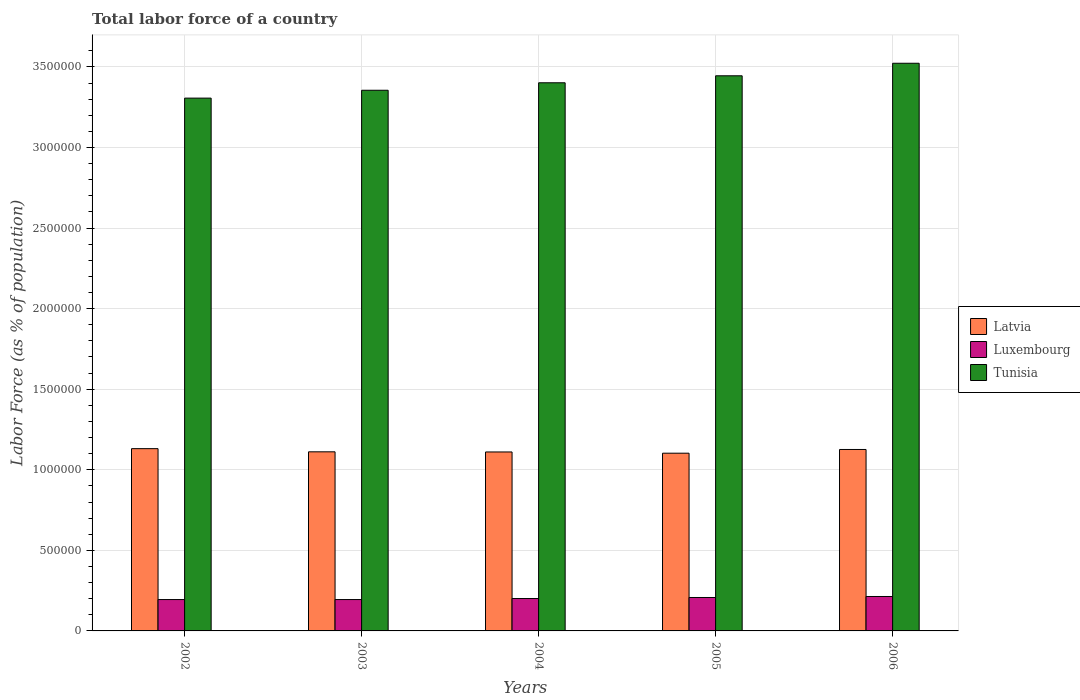How many different coloured bars are there?
Your answer should be very brief. 3. How many groups of bars are there?
Keep it short and to the point. 5. Are the number of bars on each tick of the X-axis equal?
Ensure brevity in your answer.  Yes. How many bars are there on the 2nd tick from the left?
Your response must be concise. 3. How many bars are there on the 2nd tick from the right?
Your response must be concise. 3. In how many cases, is the number of bars for a given year not equal to the number of legend labels?
Your response must be concise. 0. What is the percentage of labor force in Latvia in 2006?
Your response must be concise. 1.13e+06. Across all years, what is the maximum percentage of labor force in Tunisia?
Ensure brevity in your answer.  3.52e+06. Across all years, what is the minimum percentage of labor force in Latvia?
Offer a terse response. 1.10e+06. In which year was the percentage of labor force in Tunisia minimum?
Your answer should be compact. 2002. What is the total percentage of labor force in Latvia in the graph?
Your answer should be compact. 5.58e+06. What is the difference between the percentage of labor force in Luxembourg in 2003 and that in 2006?
Your answer should be very brief. -1.90e+04. What is the difference between the percentage of labor force in Luxembourg in 2003 and the percentage of labor force in Tunisia in 2002?
Your response must be concise. -3.11e+06. What is the average percentage of labor force in Tunisia per year?
Ensure brevity in your answer.  3.41e+06. In the year 2003, what is the difference between the percentage of labor force in Tunisia and percentage of labor force in Luxembourg?
Make the answer very short. 3.16e+06. In how many years, is the percentage of labor force in Luxembourg greater than 600000 %?
Your answer should be compact. 0. What is the ratio of the percentage of labor force in Tunisia in 2004 to that in 2005?
Make the answer very short. 0.99. What is the difference between the highest and the second highest percentage of labor force in Luxembourg?
Your answer should be compact. 6194. What is the difference between the highest and the lowest percentage of labor force in Luxembourg?
Offer a very short reply. 1.90e+04. In how many years, is the percentage of labor force in Latvia greater than the average percentage of labor force in Latvia taken over all years?
Ensure brevity in your answer.  2. Is the sum of the percentage of labor force in Latvia in 2003 and 2005 greater than the maximum percentage of labor force in Luxembourg across all years?
Give a very brief answer. Yes. What does the 2nd bar from the left in 2005 represents?
Your answer should be very brief. Luxembourg. What does the 3rd bar from the right in 2005 represents?
Make the answer very short. Latvia. Is it the case that in every year, the sum of the percentage of labor force in Tunisia and percentage of labor force in Latvia is greater than the percentage of labor force in Luxembourg?
Give a very brief answer. Yes. How many bars are there?
Keep it short and to the point. 15. Does the graph contain grids?
Offer a very short reply. Yes. How many legend labels are there?
Keep it short and to the point. 3. How are the legend labels stacked?
Keep it short and to the point. Vertical. What is the title of the graph?
Offer a terse response. Total labor force of a country. What is the label or title of the X-axis?
Your response must be concise. Years. What is the label or title of the Y-axis?
Ensure brevity in your answer.  Labor Force (as % of population). What is the Labor Force (as % of population) in Latvia in 2002?
Give a very brief answer. 1.13e+06. What is the Labor Force (as % of population) of Luxembourg in 2002?
Give a very brief answer. 1.95e+05. What is the Labor Force (as % of population) in Tunisia in 2002?
Ensure brevity in your answer.  3.31e+06. What is the Labor Force (as % of population) in Latvia in 2003?
Ensure brevity in your answer.  1.11e+06. What is the Labor Force (as % of population) in Luxembourg in 2003?
Your answer should be very brief. 1.95e+05. What is the Labor Force (as % of population) of Tunisia in 2003?
Your response must be concise. 3.36e+06. What is the Labor Force (as % of population) of Latvia in 2004?
Offer a very short reply. 1.11e+06. What is the Labor Force (as % of population) of Luxembourg in 2004?
Your answer should be compact. 2.01e+05. What is the Labor Force (as % of population) of Tunisia in 2004?
Give a very brief answer. 3.40e+06. What is the Labor Force (as % of population) in Latvia in 2005?
Provide a succinct answer. 1.10e+06. What is the Labor Force (as % of population) in Luxembourg in 2005?
Ensure brevity in your answer.  2.07e+05. What is the Labor Force (as % of population) in Tunisia in 2005?
Keep it short and to the point. 3.44e+06. What is the Labor Force (as % of population) of Latvia in 2006?
Provide a short and direct response. 1.13e+06. What is the Labor Force (as % of population) in Luxembourg in 2006?
Your answer should be compact. 2.14e+05. What is the Labor Force (as % of population) in Tunisia in 2006?
Offer a terse response. 3.52e+06. Across all years, what is the maximum Labor Force (as % of population) of Latvia?
Your response must be concise. 1.13e+06. Across all years, what is the maximum Labor Force (as % of population) in Luxembourg?
Offer a very short reply. 2.14e+05. Across all years, what is the maximum Labor Force (as % of population) of Tunisia?
Keep it short and to the point. 3.52e+06. Across all years, what is the minimum Labor Force (as % of population) in Latvia?
Your answer should be compact. 1.10e+06. Across all years, what is the minimum Labor Force (as % of population) in Luxembourg?
Provide a short and direct response. 1.95e+05. Across all years, what is the minimum Labor Force (as % of population) in Tunisia?
Keep it short and to the point. 3.31e+06. What is the total Labor Force (as % of population) in Latvia in the graph?
Provide a short and direct response. 5.58e+06. What is the total Labor Force (as % of population) of Luxembourg in the graph?
Keep it short and to the point. 1.01e+06. What is the total Labor Force (as % of population) in Tunisia in the graph?
Provide a short and direct response. 1.70e+07. What is the difference between the Labor Force (as % of population) in Latvia in 2002 and that in 2003?
Keep it short and to the point. 1.97e+04. What is the difference between the Labor Force (as % of population) in Luxembourg in 2002 and that in 2003?
Make the answer very short. 29. What is the difference between the Labor Force (as % of population) of Tunisia in 2002 and that in 2003?
Offer a terse response. -4.88e+04. What is the difference between the Labor Force (as % of population) in Latvia in 2002 and that in 2004?
Keep it short and to the point. 2.06e+04. What is the difference between the Labor Force (as % of population) in Luxembourg in 2002 and that in 2004?
Provide a short and direct response. -6340. What is the difference between the Labor Force (as % of population) in Tunisia in 2002 and that in 2004?
Provide a short and direct response. -9.52e+04. What is the difference between the Labor Force (as % of population) of Latvia in 2002 and that in 2005?
Your response must be concise. 2.82e+04. What is the difference between the Labor Force (as % of population) of Luxembourg in 2002 and that in 2005?
Keep it short and to the point. -1.27e+04. What is the difference between the Labor Force (as % of population) in Tunisia in 2002 and that in 2005?
Your answer should be very brief. -1.39e+05. What is the difference between the Labor Force (as % of population) in Latvia in 2002 and that in 2006?
Your response must be concise. 5134. What is the difference between the Labor Force (as % of population) in Luxembourg in 2002 and that in 2006?
Provide a succinct answer. -1.89e+04. What is the difference between the Labor Force (as % of population) in Tunisia in 2002 and that in 2006?
Your answer should be compact. -2.16e+05. What is the difference between the Labor Force (as % of population) in Latvia in 2003 and that in 2004?
Offer a terse response. 829. What is the difference between the Labor Force (as % of population) in Luxembourg in 2003 and that in 2004?
Your response must be concise. -6369. What is the difference between the Labor Force (as % of population) of Tunisia in 2003 and that in 2004?
Keep it short and to the point. -4.65e+04. What is the difference between the Labor Force (as % of population) of Latvia in 2003 and that in 2005?
Your answer should be very brief. 8469. What is the difference between the Labor Force (as % of population) of Luxembourg in 2003 and that in 2005?
Make the answer very short. -1.28e+04. What is the difference between the Labor Force (as % of population) in Tunisia in 2003 and that in 2005?
Give a very brief answer. -8.98e+04. What is the difference between the Labor Force (as % of population) of Latvia in 2003 and that in 2006?
Provide a short and direct response. -1.46e+04. What is the difference between the Labor Force (as % of population) of Luxembourg in 2003 and that in 2006?
Give a very brief answer. -1.90e+04. What is the difference between the Labor Force (as % of population) in Tunisia in 2003 and that in 2006?
Your response must be concise. -1.68e+05. What is the difference between the Labor Force (as % of population) of Latvia in 2004 and that in 2005?
Offer a terse response. 7640. What is the difference between the Labor Force (as % of population) of Luxembourg in 2004 and that in 2005?
Your answer should be very brief. -6407. What is the difference between the Labor Force (as % of population) in Tunisia in 2004 and that in 2005?
Keep it short and to the point. -4.34e+04. What is the difference between the Labor Force (as % of population) of Latvia in 2004 and that in 2006?
Provide a short and direct response. -1.54e+04. What is the difference between the Labor Force (as % of population) of Luxembourg in 2004 and that in 2006?
Your response must be concise. -1.26e+04. What is the difference between the Labor Force (as % of population) of Tunisia in 2004 and that in 2006?
Your response must be concise. -1.21e+05. What is the difference between the Labor Force (as % of population) of Latvia in 2005 and that in 2006?
Give a very brief answer. -2.31e+04. What is the difference between the Labor Force (as % of population) in Luxembourg in 2005 and that in 2006?
Provide a succinct answer. -6194. What is the difference between the Labor Force (as % of population) in Tunisia in 2005 and that in 2006?
Offer a very short reply. -7.77e+04. What is the difference between the Labor Force (as % of population) of Latvia in 2002 and the Labor Force (as % of population) of Luxembourg in 2003?
Provide a short and direct response. 9.36e+05. What is the difference between the Labor Force (as % of population) in Latvia in 2002 and the Labor Force (as % of population) in Tunisia in 2003?
Keep it short and to the point. -2.22e+06. What is the difference between the Labor Force (as % of population) in Luxembourg in 2002 and the Labor Force (as % of population) in Tunisia in 2003?
Offer a very short reply. -3.16e+06. What is the difference between the Labor Force (as % of population) of Latvia in 2002 and the Labor Force (as % of population) of Luxembourg in 2004?
Your response must be concise. 9.30e+05. What is the difference between the Labor Force (as % of population) in Latvia in 2002 and the Labor Force (as % of population) in Tunisia in 2004?
Offer a very short reply. -2.27e+06. What is the difference between the Labor Force (as % of population) of Luxembourg in 2002 and the Labor Force (as % of population) of Tunisia in 2004?
Provide a succinct answer. -3.21e+06. What is the difference between the Labor Force (as % of population) of Latvia in 2002 and the Labor Force (as % of population) of Luxembourg in 2005?
Make the answer very short. 9.24e+05. What is the difference between the Labor Force (as % of population) of Latvia in 2002 and the Labor Force (as % of population) of Tunisia in 2005?
Keep it short and to the point. -2.31e+06. What is the difference between the Labor Force (as % of population) of Luxembourg in 2002 and the Labor Force (as % of population) of Tunisia in 2005?
Your answer should be compact. -3.25e+06. What is the difference between the Labor Force (as % of population) of Latvia in 2002 and the Labor Force (as % of population) of Luxembourg in 2006?
Your answer should be very brief. 9.17e+05. What is the difference between the Labor Force (as % of population) of Latvia in 2002 and the Labor Force (as % of population) of Tunisia in 2006?
Your answer should be compact. -2.39e+06. What is the difference between the Labor Force (as % of population) in Luxembourg in 2002 and the Labor Force (as % of population) in Tunisia in 2006?
Ensure brevity in your answer.  -3.33e+06. What is the difference between the Labor Force (as % of population) of Latvia in 2003 and the Labor Force (as % of population) of Luxembourg in 2004?
Offer a very short reply. 9.10e+05. What is the difference between the Labor Force (as % of population) of Latvia in 2003 and the Labor Force (as % of population) of Tunisia in 2004?
Keep it short and to the point. -2.29e+06. What is the difference between the Labor Force (as % of population) of Luxembourg in 2003 and the Labor Force (as % of population) of Tunisia in 2004?
Provide a succinct answer. -3.21e+06. What is the difference between the Labor Force (as % of population) in Latvia in 2003 and the Labor Force (as % of population) in Luxembourg in 2005?
Offer a very short reply. 9.04e+05. What is the difference between the Labor Force (as % of population) of Latvia in 2003 and the Labor Force (as % of population) of Tunisia in 2005?
Give a very brief answer. -2.33e+06. What is the difference between the Labor Force (as % of population) of Luxembourg in 2003 and the Labor Force (as % of population) of Tunisia in 2005?
Offer a terse response. -3.25e+06. What is the difference between the Labor Force (as % of population) in Latvia in 2003 and the Labor Force (as % of population) in Luxembourg in 2006?
Your response must be concise. 8.98e+05. What is the difference between the Labor Force (as % of population) of Latvia in 2003 and the Labor Force (as % of population) of Tunisia in 2006?
Your answer should be very brief. -2.41e+06. What is the difference between the Labor Force (as % of population) of Luxembourg in 2003 and the Labor Force (as % of population) of Tunisia in 2006?
Offer a very short reply. -3.33e+06. What is the difference between the Labor Force (as % of population) in Latvia in 2004 and the Labor Force (as % of population) in Luxembourg in 2005?
Your response must be concise. 9.03e+05. What is the difference between the Labor Force (as % of population) of Latvia in 2004 and the Labor Force (as % of population) of Tunisia in 2005?
Provide a short and direct response. -2.33e+06. What is the difference between the Labor Force (as % of population) of Luxembourg in 2004 and the Labor Force (as % of population) of Tunisia in 2005?
Ensure brevity in your answer.  -3.24e+06. What is the difference between the Labor Force (as % of population) in Latvia in 2004 and the Labor Force (as % of population) in Luxembourg in 2006?
Keep it short and to the point. 8.97e+05. What is the difference between the Labor Force (as % of population) in Latvia in 2004 and the Labor Force (as % of population) in Tunisia in 2006?
Give a very brief answer. -2.41e+06. What is the difference between the Labor Force (as % of population) of Luxembourg in 2004 and the Labor Force (as % of population) of Tunisia in 2006?
Offer a terse response. -3.32e+06. What is the difference between the Labor Force (as % of population) of Latvia in 2005 and the Labor Force (as % of population) of Luxembourg in 2006?
Provide a succinct answer. 8.89e+05. What is the difference between the Labor Force (as % of population) of Latvia in 2005 and the Labor Force (as % of population) of Tunisia in 2006?
Keep it short and to the point. -2.42e+06. What is the difference between the Labor Force (as % of population) in Luxembourg in 2005 and the Labor Force (as % of population) in Tunisia in 2006?
Keep it short and to the point. -3.32e+06. What is the average Labor Force (as % of population) in Latvia per year?
Give a very brief answer. 1.12e+06. What is the average Labor Force (as % of population) of Luxembourg per year?
Your answer should be compact. 2.02e+05. What is the average Labor Force (as % of population) of Tunisia per year?
Provide a succinct answer. 3.41e+06. In the year 2002, what is the difference between the Labor Force (as % of population) in Latvia and Labor Force (as % of population) in Luxembourg?
Offer a very short reply. 9.36e+05. In the year 2002, what is the difference between the Labor Force (as % of population) of Latvia and Labor Force (as % of population) of Tunisia?
Provide a succinct answer. -2.18e+06. In the year 2002, what is the difference between the Labor Force (as % of population) of Luxembourg and Labor Force (as % of population) of Tunisia?
Your response must be concise. -3.11e+06. In the year 2003, what is the difference between the Labor Force (as % of population) of Latvia and Labor Force (as % of population) of Luxembourg?
Offer a terse response. 9.17e+05. In the year 2003, what is the difference between the Labor Force (as % of population) of Latvia and Labor Force (as % of population) of Tunisia?
Make the answer very short. -2.24e+06. In the year 2003, what is the difference between the Labor Force (as % of population) of Luxembourg and Labor Force (as % of population) of Tunisia?
Offer a terse response. -3.16e+06. In the year 2004, what is the difference between the Labor Force (as % of population) in Latvia and Labor Force (as % of population) in Luxembourg?
Provide a short and direct response. 9.10e+05. In the year 2004, what is the difference between the Labor Force (as % of population) in Latvia and Labor Force (as % of population) in Tunisia?
Offer a very short reply. -2.29e+06. In the year 2004, what is the difference between the Labor Force (as % of population) of Luxembourg and Labor Force (as % of population) of Tunisia?
Keep it short and to the point. -3.20e+06. In the year 2005, what is the difference between the Labor Force (as % of population) of Latvia and Labor Force (as % of population) of Luxembourg?
Make the answer very short. 8.95e+05. In the year 2005, what is the difference between the Labor Force (as % of population) in Latvia and Labor Force (as % of population) in Tunisia?
Provide a succinct answer. -2.34e+06. In the year 2005, what is the difference between the Labor Force (as % of population) of Luxembourg and Labor Force (as % of population) of Tunisia?
Provide a short and direct response. -3.24e+06. In the year 2006, what is the difference between the Labor Force (as % of population) of Latvia and Labor Force (as % of population) of Luxembourg?
Give a very brief answer. 9.12e+05. In the year 2006, what is the difference between the Labor Force (as % of population) in Latvia and Labor Force (as % of population) in Tunisia?
Give a very brief answer. -2.40e+06. In the year 2006, what is the difference between the Labor Force (as % of population) in Luxembourg and Labor Force (as % of population) in Tunisia?
Make the answer very short. -3.31e+06. What is the ratio of the Labor Force (as % of population) of Latvia in 2002 to that in 2003?
Provide a succinct answer. 1.02. What is the ratio of the Labor Force (as % of population) of Tunisia in 2002 to that in 2003?
Ensure brevity in your answer.  0.99. What is the ratio of the Labor Force (as % of population) in Latvia in 2002 to that in 2004?
Provide a succinct answer. 1.02. What is the ratio of the Labor Force (as % of population) in Luxembourg in 2002 to that in 2004?
Provide a short and direct response. 0.97. What is the ratio of the Labor Force (as % of population) in Tunisia in 2002 to that in 2004?
Your answer should be compact. 0.97. What is the ratio of the Labor Force (as % of population) in Latvia in 2002 to that in 2005?
Give a very brief answer. 1.03. What is the ratio of the Labor Force (as % of population) in Luxembourg in 2002 to that in 2005?
Provide a short and direct response. 0.94. What is the ratio of the Labor Force (as % of population) in Tunisia in 2002 to that in 2005?
Give a very brief answer. 0.96. What is the ratio of the Labor Force (as % of population) of Luxembourg in 2002 to that in 2006?
Your answer should be compact. 0.91. What is the ratio of the Labor Force (as % of population) of Tunisia in 2002 to that in 2006?
Provide a short and direct response. 0.94. What is the ratio of the Labor Force (as % of population) of Luxembourg in 2003 to that in 2004?
Ensure brevity in your answer.  0.97. What is the ratio of the Labor Force (as % of population) of Tunisia in 2003 to that in 2004?
Offer a very short reply. 0.99. What is the ratio of the Labor Force (as % of population) in Latvia in 2003 to that in 2005?
Provide a succinct answer. 1.01. What is the ratio of the Labor Force (as % of population) of Luxembourg in 2003 to that in 2005?
Offer a very short reply. 0.94. What is the ratio of the Labor Force (as % of population) in Tunisia in 2003 to that in 2005?
Ensure brevity in your answer.  0.97. What is the ratio of the Labor Force (as % of population) in Latvia in 2003 to that in 2006?
Give a very brief answer. 0.99. What is the ratio of the Labor Force (as % of population) in Luxembourg in 2003 to that in 2006?
Ensure brevity in your answer.  0.91. What is the ratio of the Labor Force (as % of population) of Tunisia in 2003 to that in 2006?
Provide a short and direct response. 0.95. What is the ratio of the Labor Force (as % of population) in Latvia in 2004 to that in 2005?
Keep it short and to the point. 1.01. What is the ratio of the Labor Force (as % of population) in Luxembourg in 2004 to that in 2005?
Offer a terse response. 0.97. What is the ratio of the Labor Force (as % of population) of Tunisia in 2004 to that in 2005?
Keep it short and to the point. 0.99. What is the ratio of the Labor Force (as % of population) in Latvia in 2004 to that in 2006?
Keep it short and to the point. 0.99. What is the ratio of the Labor Force (as % of population) of Luxembourg in 2004 to that in 2006?
Your answer should be compact. 0.94. What is the ratio of the Labor Force (as % of population) of Tunisia in 2004 to that in 2006?
Your answer should be compact. 0.97. What is the ratio of the Labor Force (as % of population) of Latvia in 2005 to that in 2006?
Offer a terse response. 0.98. What is the ratio of the Labor Force (as % of population) of Tunisia in 2005 to that in 2006?
Your answer should be compact. 0.98. What is the difference between the highest and the second highest Labor Force (as % of population) in Latvia?
Your answer should be compact. 5134. What is the difference between the highest and the second highest Labor Force (as % of population) in Luxembourg?
Ensure brevity in your answer.  6194. What is the difference between the highest and the second highest Labor Force (as % of population) in Tunisia?
Offer a terse response. 7.77e+04. What is the difference between the highest and the lowest Labor Force (as % of population) of Latvia?
Provide a succinct answer. 2.82e+04. What is the difference between the highest and the lowest Labor Force (as % of population) in Luxembourg?
Your response must be concise. 1.90e+04. What is the difference between the highest and the lowest Labor Force (as % of population) in Tunisia?
Your response must be concise. 2.16e+05. 